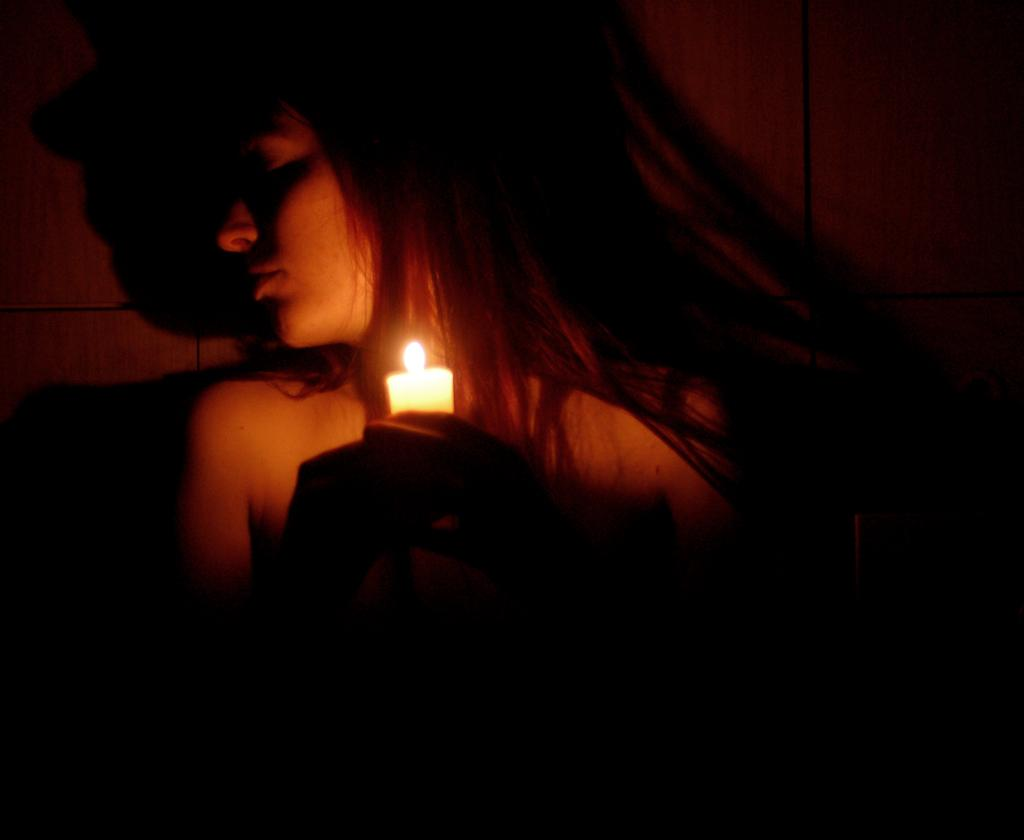Who is the main subject in the image? There is a woman in the image. What is the woman holding in the image? The woman is holding a candle. What color is the wall in the background of the image? The wall in the background of the image is brown. How would you describe the lighting in the image? The image appears to be dark. What type of attraction is the woman visiting in the image? There is no indication of an attraction in the image; it only shows a woman holding a candle with a brown wall in the background. What type of linen is draped over the woman's shoulders in the image? There is no linen visible in the image; the woman is simply holding a candle. 